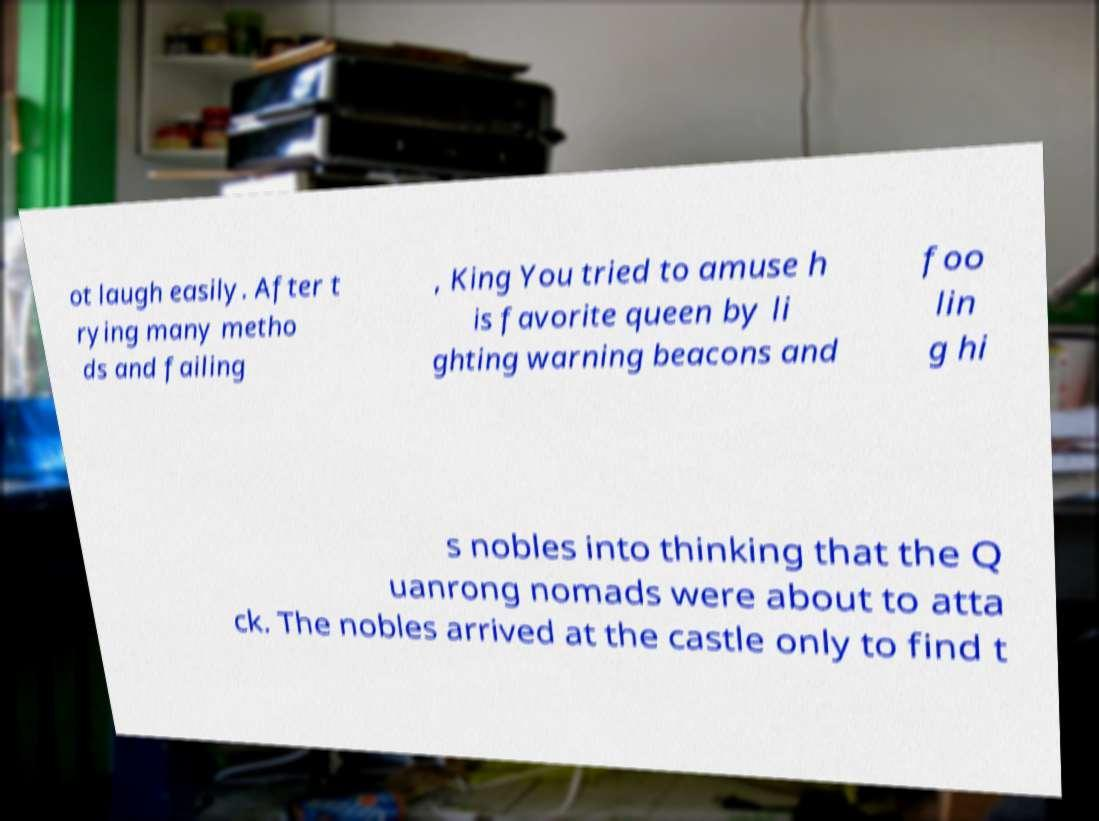Could you extract and type out the text from this image? ot laugh easily. After t rying many metho ds and failing , King You tried to amuse h is favorite queen by li ghting warning beacons and foo lin g hi s nobles into thinking that the Q uanrong nomads were about to atta ck. The nobles arrived at the castle only to find t 